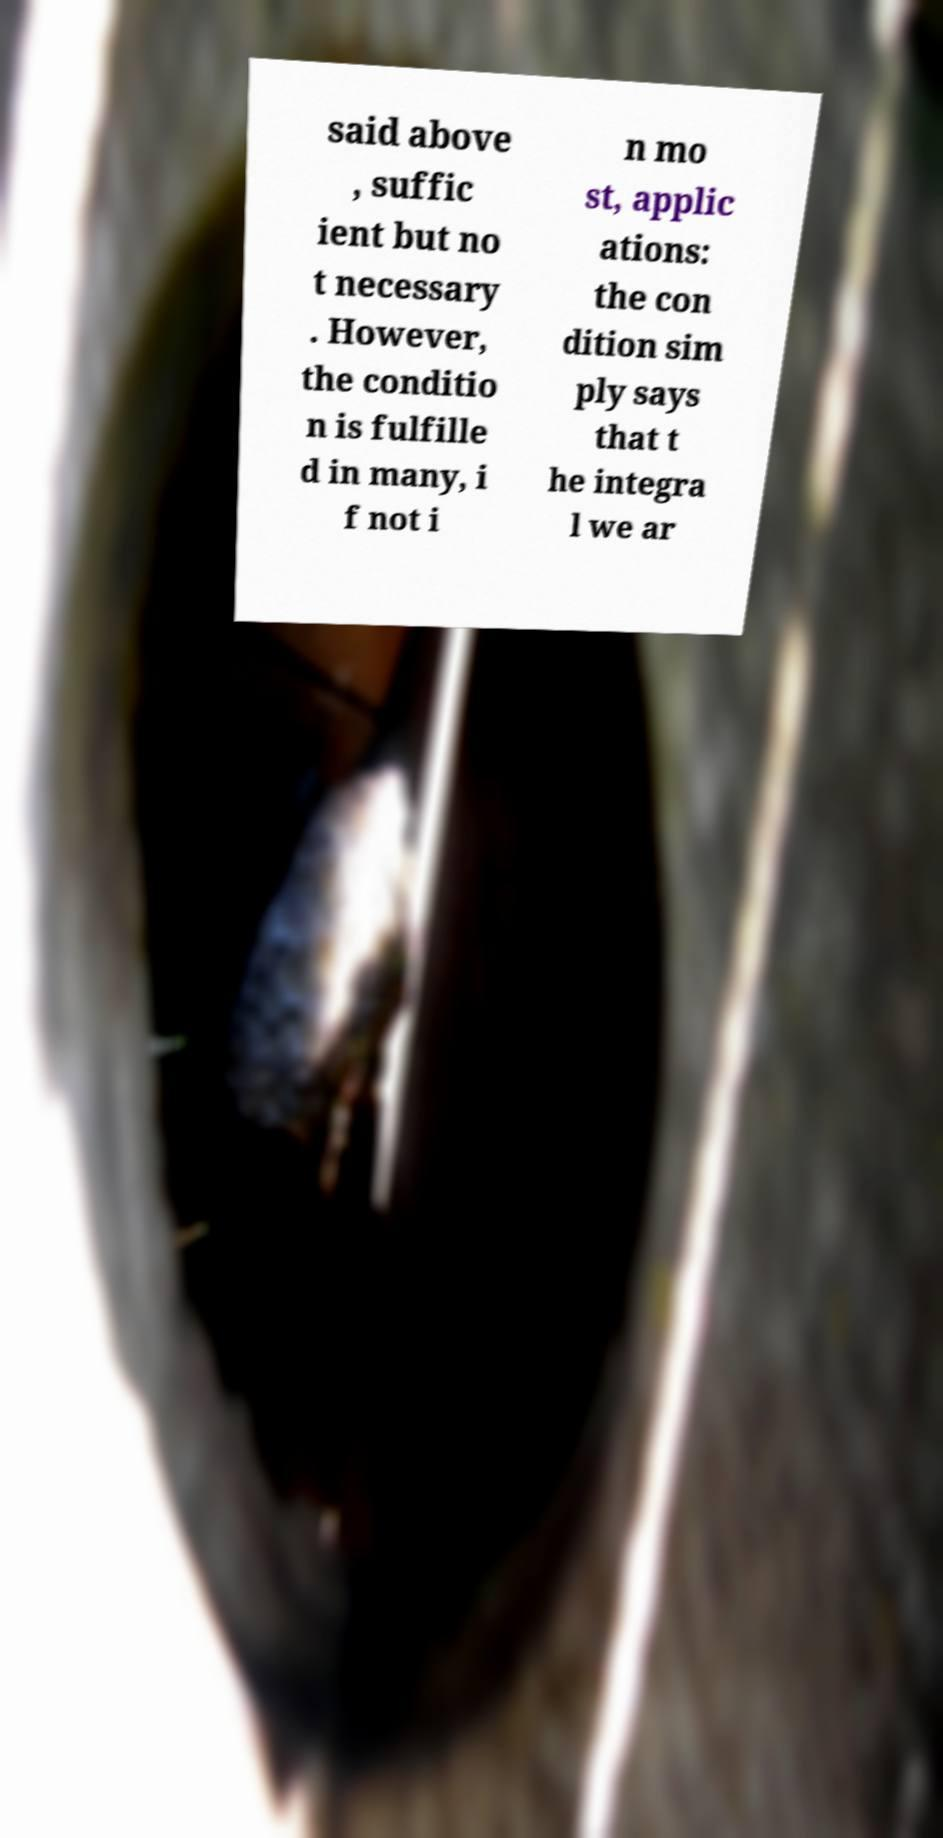Please read and relay the text visible in this image. What does it say? said above , suffic ient but no t necessary . However, the conditio n is fulfille d in many, i f not i n mo st, applic ations: the con dition sim ply says that t he integra l we ar 